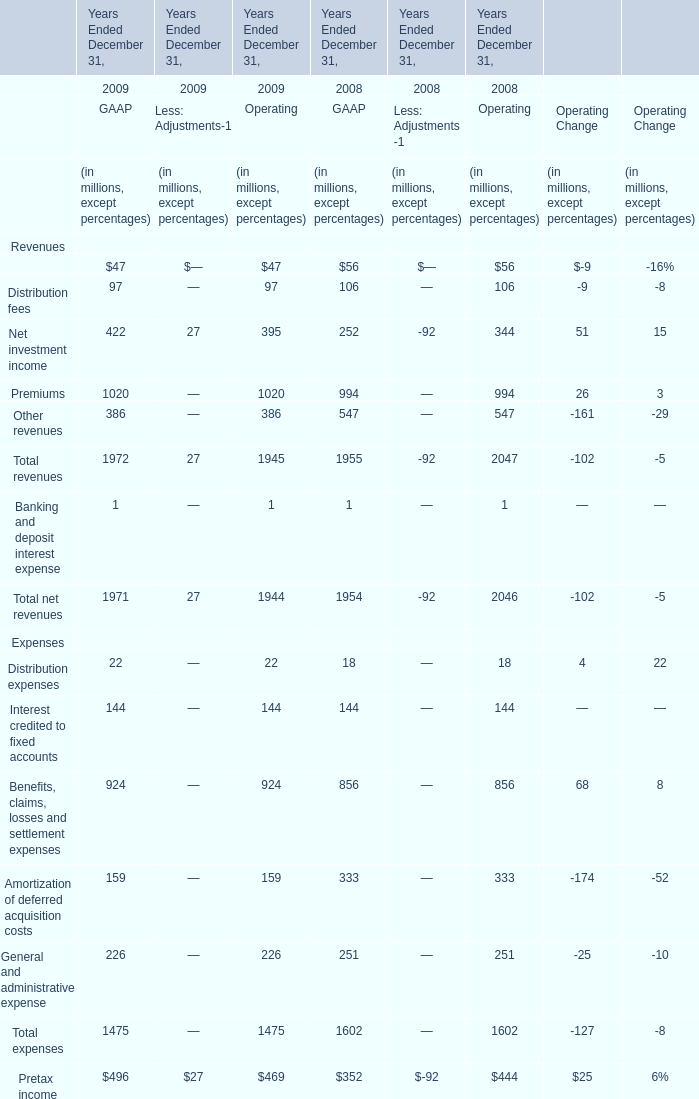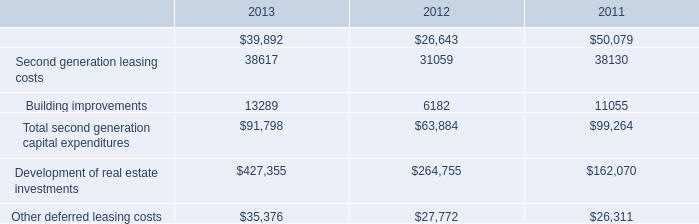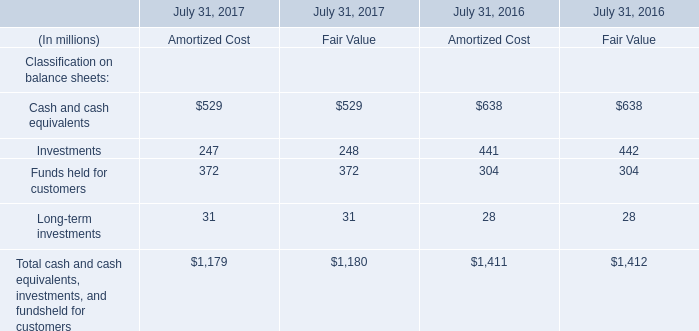what was the average cash outflows for real estate development investments from 2011 to 2013 
Computations: (((162.1 + (427.4 + 264.8)) + 3) / 2)
Answer: 428.65. 